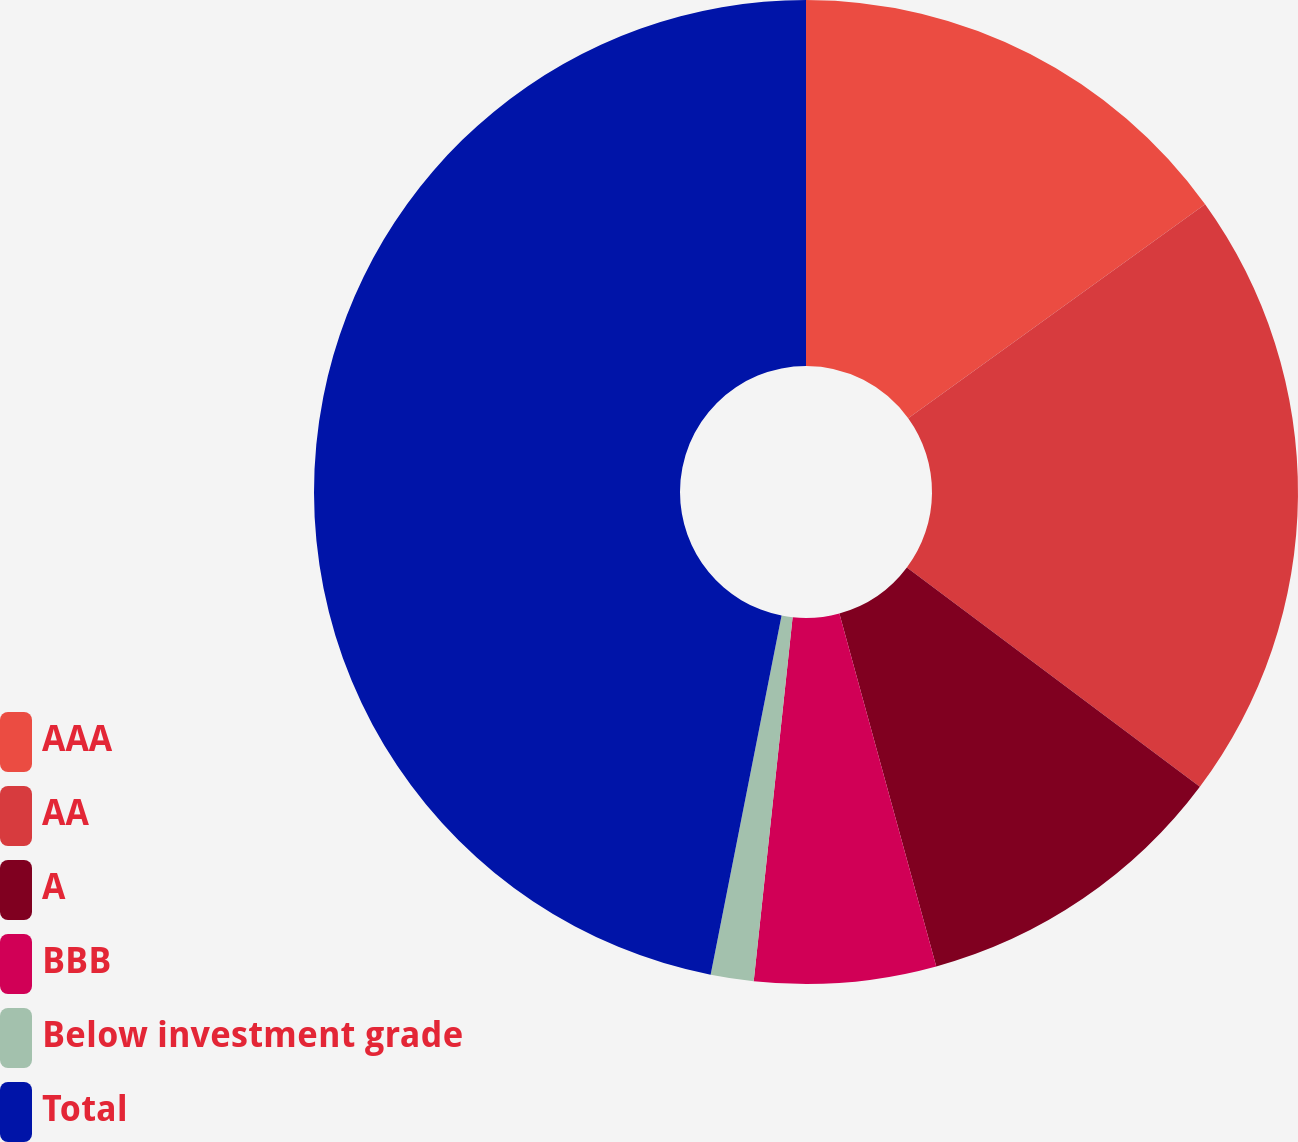Convert chart. <chart><loc_0><loc_0><loc_500><loc_500><pie_chart><fcel>AAA<fcel>AA<fcel>A<fcel>BBB<fcel>Below investment grade<fcel>Total<nl><fcel>15.06%<fcel>20.17%<fcel>10.51%<fcel>5.96%<fcel>1.41%<fcel>46.9%<nl></chart> 